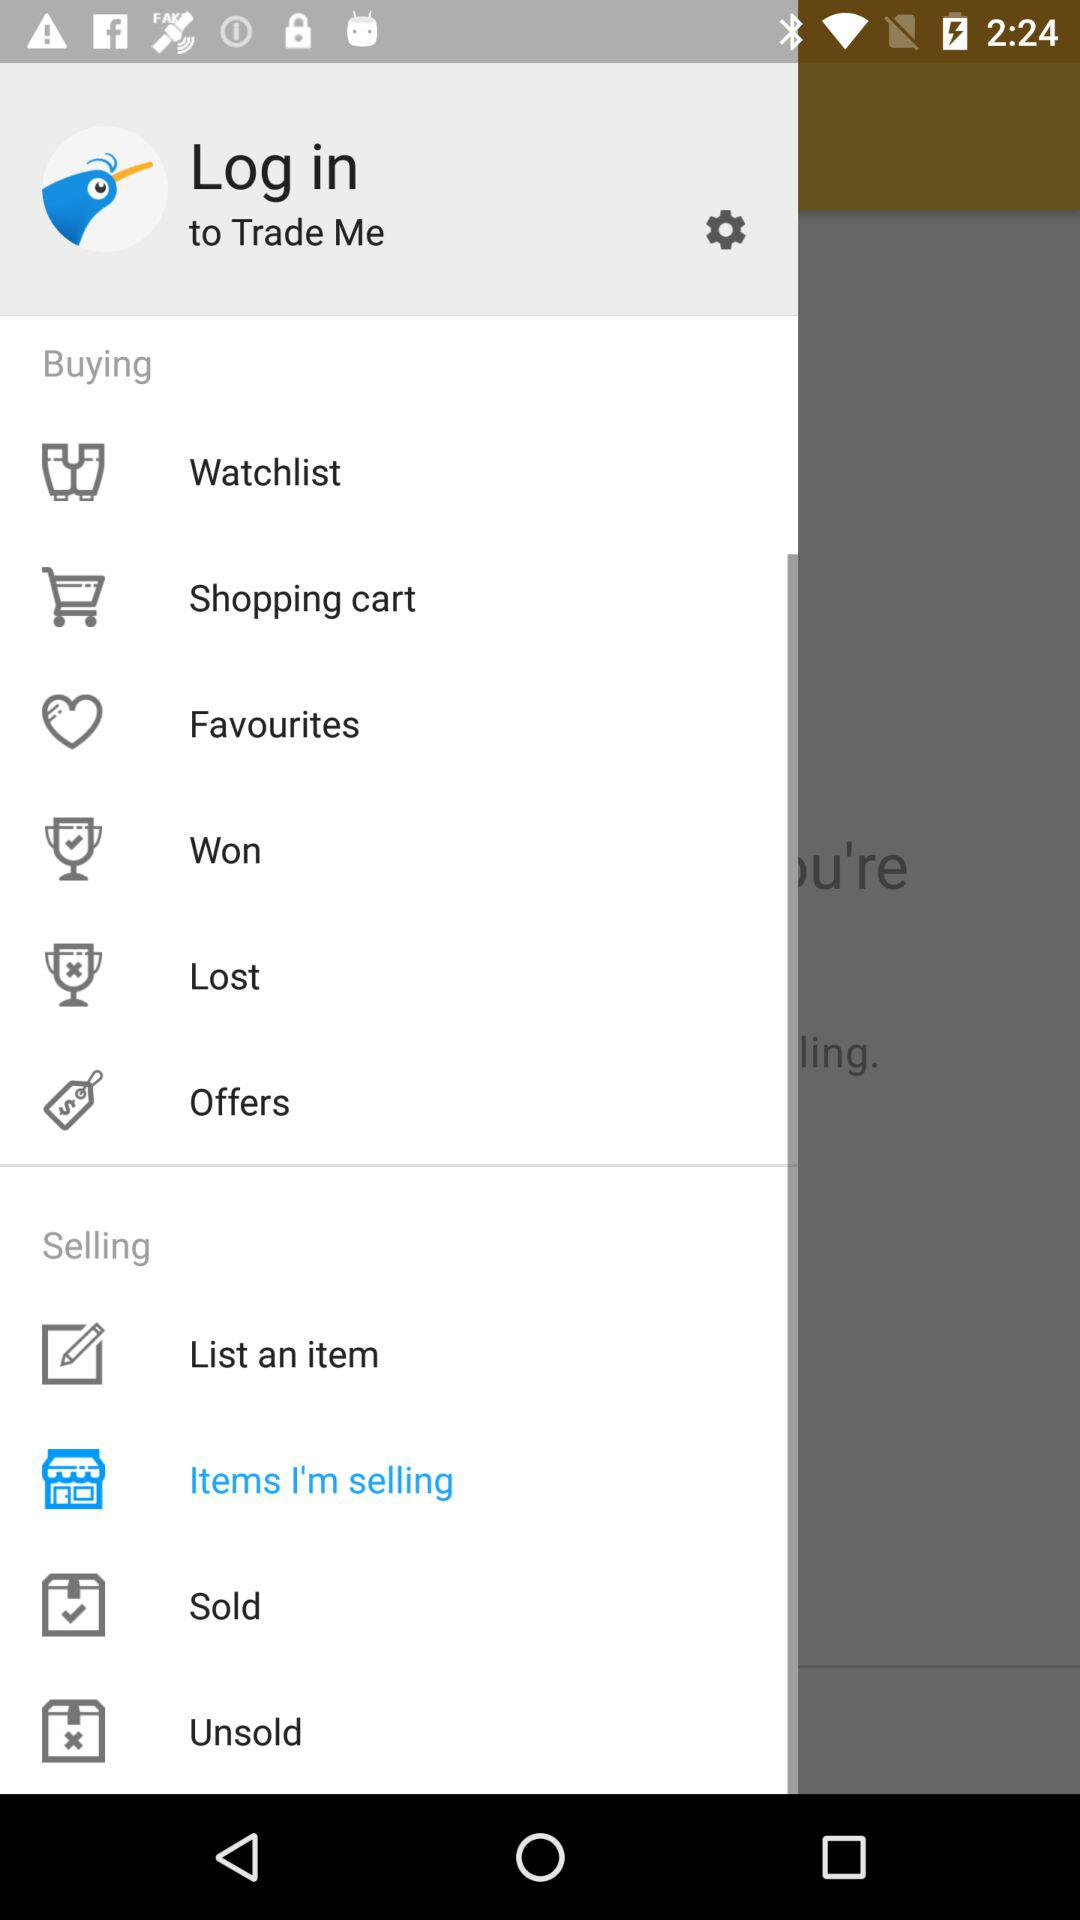Which option is selected in "Selling" menu bar? The selected option is "Items I'm selling". 